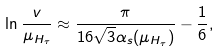Convert formula to latex. <formula><loc_0><loc_0><loc_500><loc_500>\ln \frac { v } { \mu _ { H _ { \tau } } } \approx \frac { \pi } { 1 6 \sqrt { 3 } \alpha _ { s } ( \mu _ { H _ { \tau } } ) } - \frac { 1 } { 6 } ,</formula> 